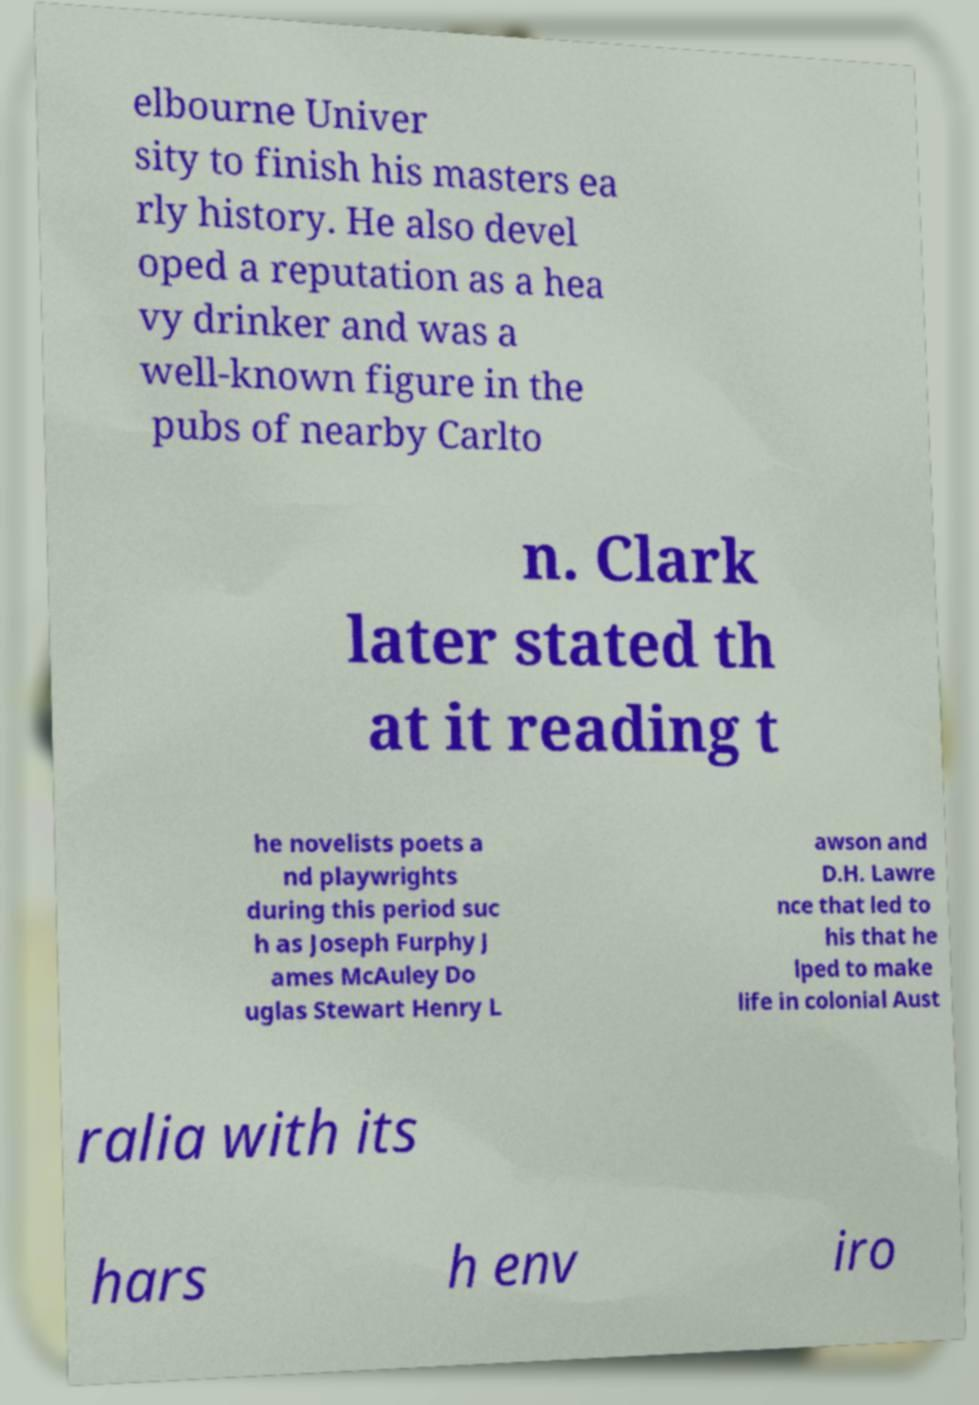Can you read and provide the text displayed in the image?This photo seems to have some interesting text. Can you extract and type it out for me? elbourne Univer sity to finish his masters ea rly history. He also devel oped a reputation as a hea vy drinker and was a well-known figure in the pubs of nearby Carlto n. Clark later stated th at it reading t he novelists poets a nd playwrights during this period suc h as Joseph Furphy J ames McAuley Do uglas Stewart Henry L awson and D.H. Lawre nce that led to his that he lped to make life in colonial Aust ralia with its hars h env iro 